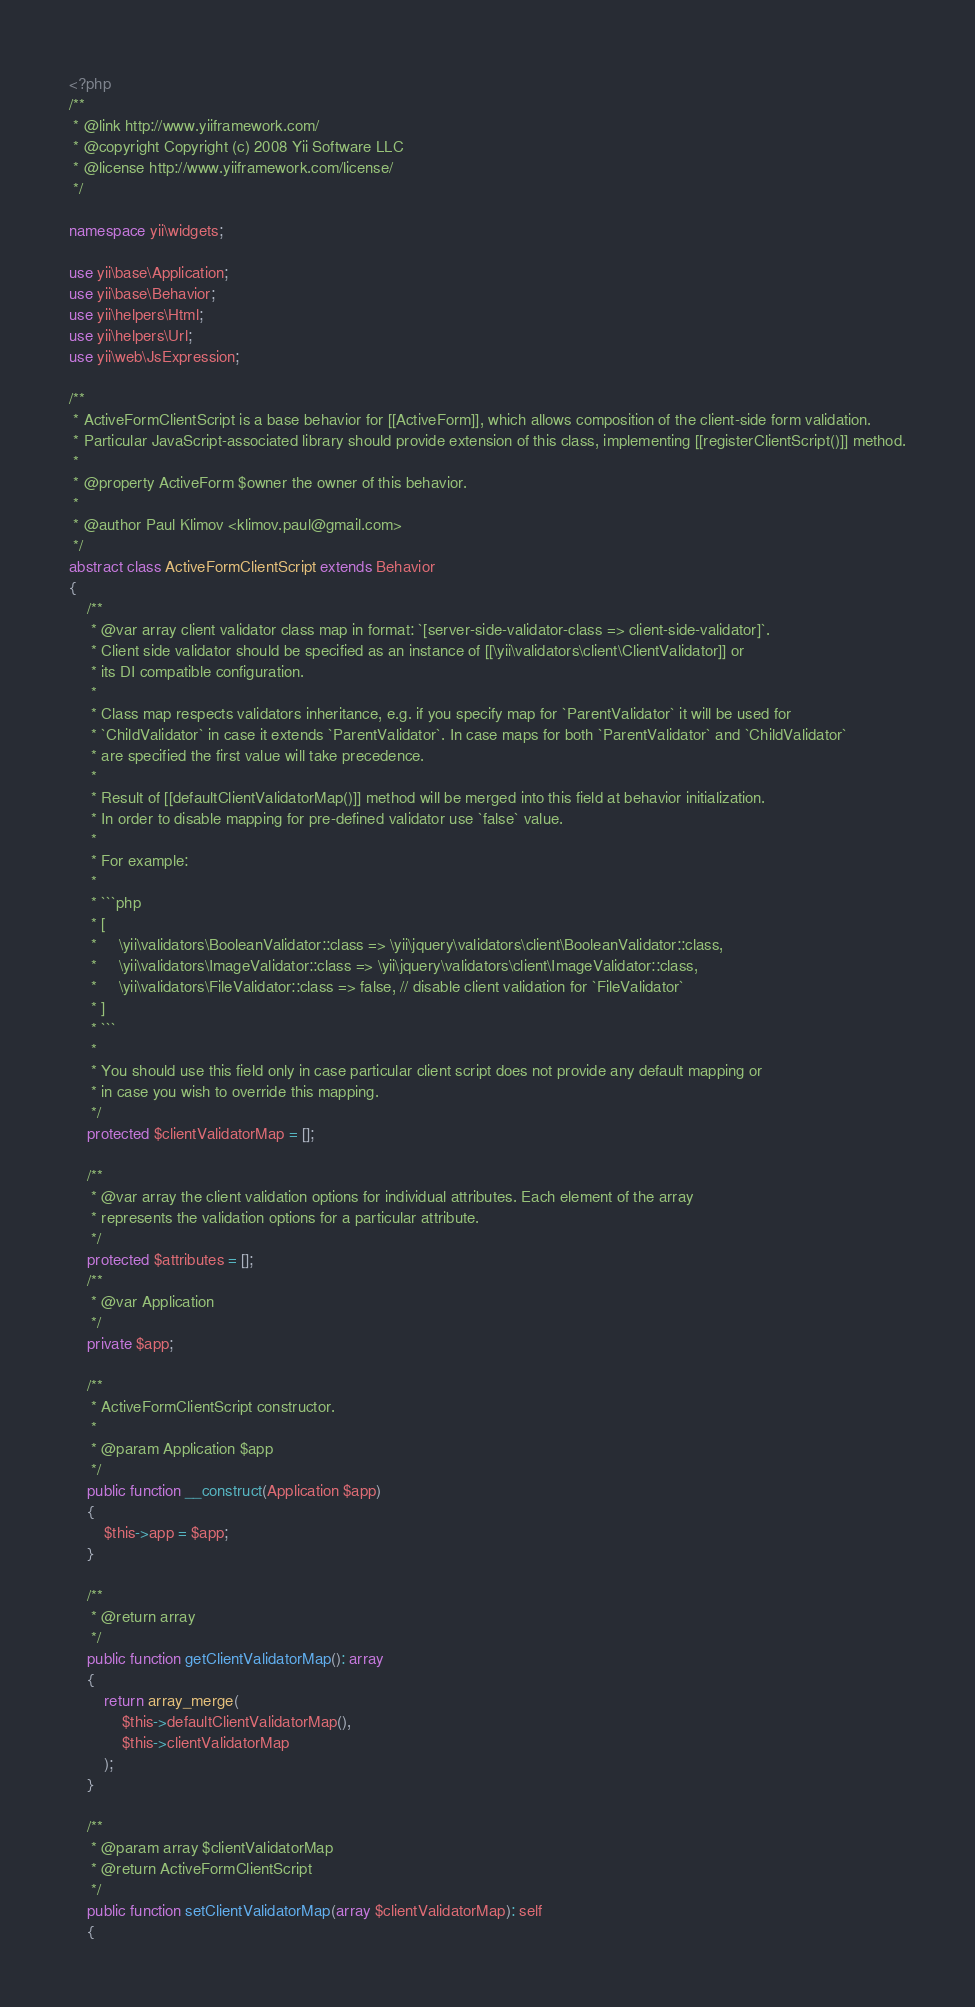<code> <loc_0><loc_0><loc_500><loc_500><_PHP_><?php
/**
 * @link http://www.yiiframework.com/
 * @copyright Copyright (c) 2008 Yii Software LLC
 * @license http://www.yiiframework.com/license/
 */

namespace yii\widgets;

use yii\base\Application;
use yii\base\Behavior;
use yii\helpers\Html;
use yii\helpers\Url;
use yii\web\JsExpression;

/**
 * ActiveFormClientScript is a base behavior for [[ActiveForm]], which allows composition of the client-side form validation.
 * Particular JavaScript-associated library should provide extension of this class, implementing [[registerClientScript()]] method.
 *
 * @property ActiveForm $owner the owner of this behavior.
 *
 * @author Paul Klimov <klimov.paul@gmail.com>
 */
abstract class ActiveFormClientScript extends Behavior
{
    /**
     * @var array client validator class map in format: `[server-side-validator-class => client-side-validator]`.
     * Client side validator should be specified as an instance of [[\yii\validators\client\ClientValidator]] or
     * its DI compatible configuration.
     *
     * Class map respects validators inheritance, e.g. if you specify map for `ParentValidator` it will be used for
     * `ChildValidator` in case it extends `ParentValidator`. In case maps for both `ParentValidator` and `ChildValidator`
     * are specified the first value will take precedence.
     *
     * Result of [[defaultClientValidatorMap()]] method will be merged into this field at behavior initialization.
     * In order to disable mapping for pre-defined validator use `false` value.
     *
     * For example:
     *
     * ```php
     * [
     *     \yii\validators\BooleanValidator::class => \yii\jquery\validators\client\BooleanValidator::class,
     *     \yii\validators\ImageValidator::class => \yii\jquery\validators\client\ImageValidator::class,
     *     \yii\validators\FileValidator::class => false, // disable client validation for `FileValidator`
     * ]
     * ```
     *
     * You should use this field only in case particular client script does not provide any default mapping or
     * in case you wish to override this mapping.
     */
    protected $clientValidatorMap = [];

    /**
     * @var array the client validation options for individual attributes. Each element of the array
     * represents the validation options for a particular attribute.
     */
    protected $attributes = [];
    /**
     * @var Application
     */
    private $app;

    /**
     * ActiveFormClientScript constructor.
     *
     * @param Application $app
     */
    public function __construct(Application $app)
    {
        $this->app = $app;
    }

    /**
     * @return array
     */
    public function getClientValidatorMap(): array
    {
        return array_merge(
            $this->defaultClientValidatorMap(),
            $this->clientValidatorMap
        );
    }

    /**
     * @param array $clientValidatorMap
     * @return ActiveFormClientScript
     */
    public function setClientValidatorMap(array $clientValidatorMap): self
    {</code> 